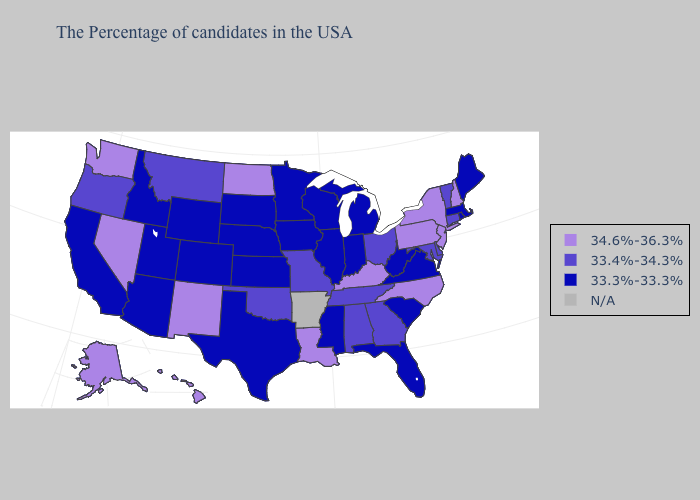What is the value of Connecticut?
Concise answer only. 33.4%-34.3%. Name the states that have a value in the range N/A?
Answer briefly. Arkansas. Name the states that have a value in the range 34.6%-36.3%?
Quick response, please. New Hampshire, New York, New Jersey, Pennsylvania, North Carolina, Kentucky, Louisiana, North Dakota, New Mexico, Nevada, Washington, Alaska, Hawaii. Does Connecticut have the highest value in the Northeast?
Short answer required. No. Is the legend a continuous bar?
Be succinct. No. How many symbols are there in the legend?
Answer briefly. 4. What is the lowest value in the USA?
Quick response, please. 33.3%-33.3%. What is the lowest value in the USA?
Short answer required. 33.3%-33.3%. What is the value of Iowa?
Give a very brief answer. 33.3%-33.3%. Among the states that border Washington , does Idaho have the lowest value?
Answer briefly. Yes. Is the legend a continuous bar?
Quick response, please. No. Name the states that have a value in the range N/A?
Be succinct. Arkansas. What is the value of North Carolina?
Keep it brief. 34.6%-36.3%. Which states have the lowest value in the USA?
Short answer required. Maine, Massachusetts, Rhode Island, Virginia, South Carolina, West Virginia, Florida, Michigan, Indiana, Wisconsin, Illinois, Mississippi, Minnesota, Iowa, Kansas, Nebraska, Texas, South Dakota, Wyoming, Colorado, Utah, Arizona, Idaho, California. What is the value of North Dakota?
Give a very brief answer. 34.6%-36.3%. 